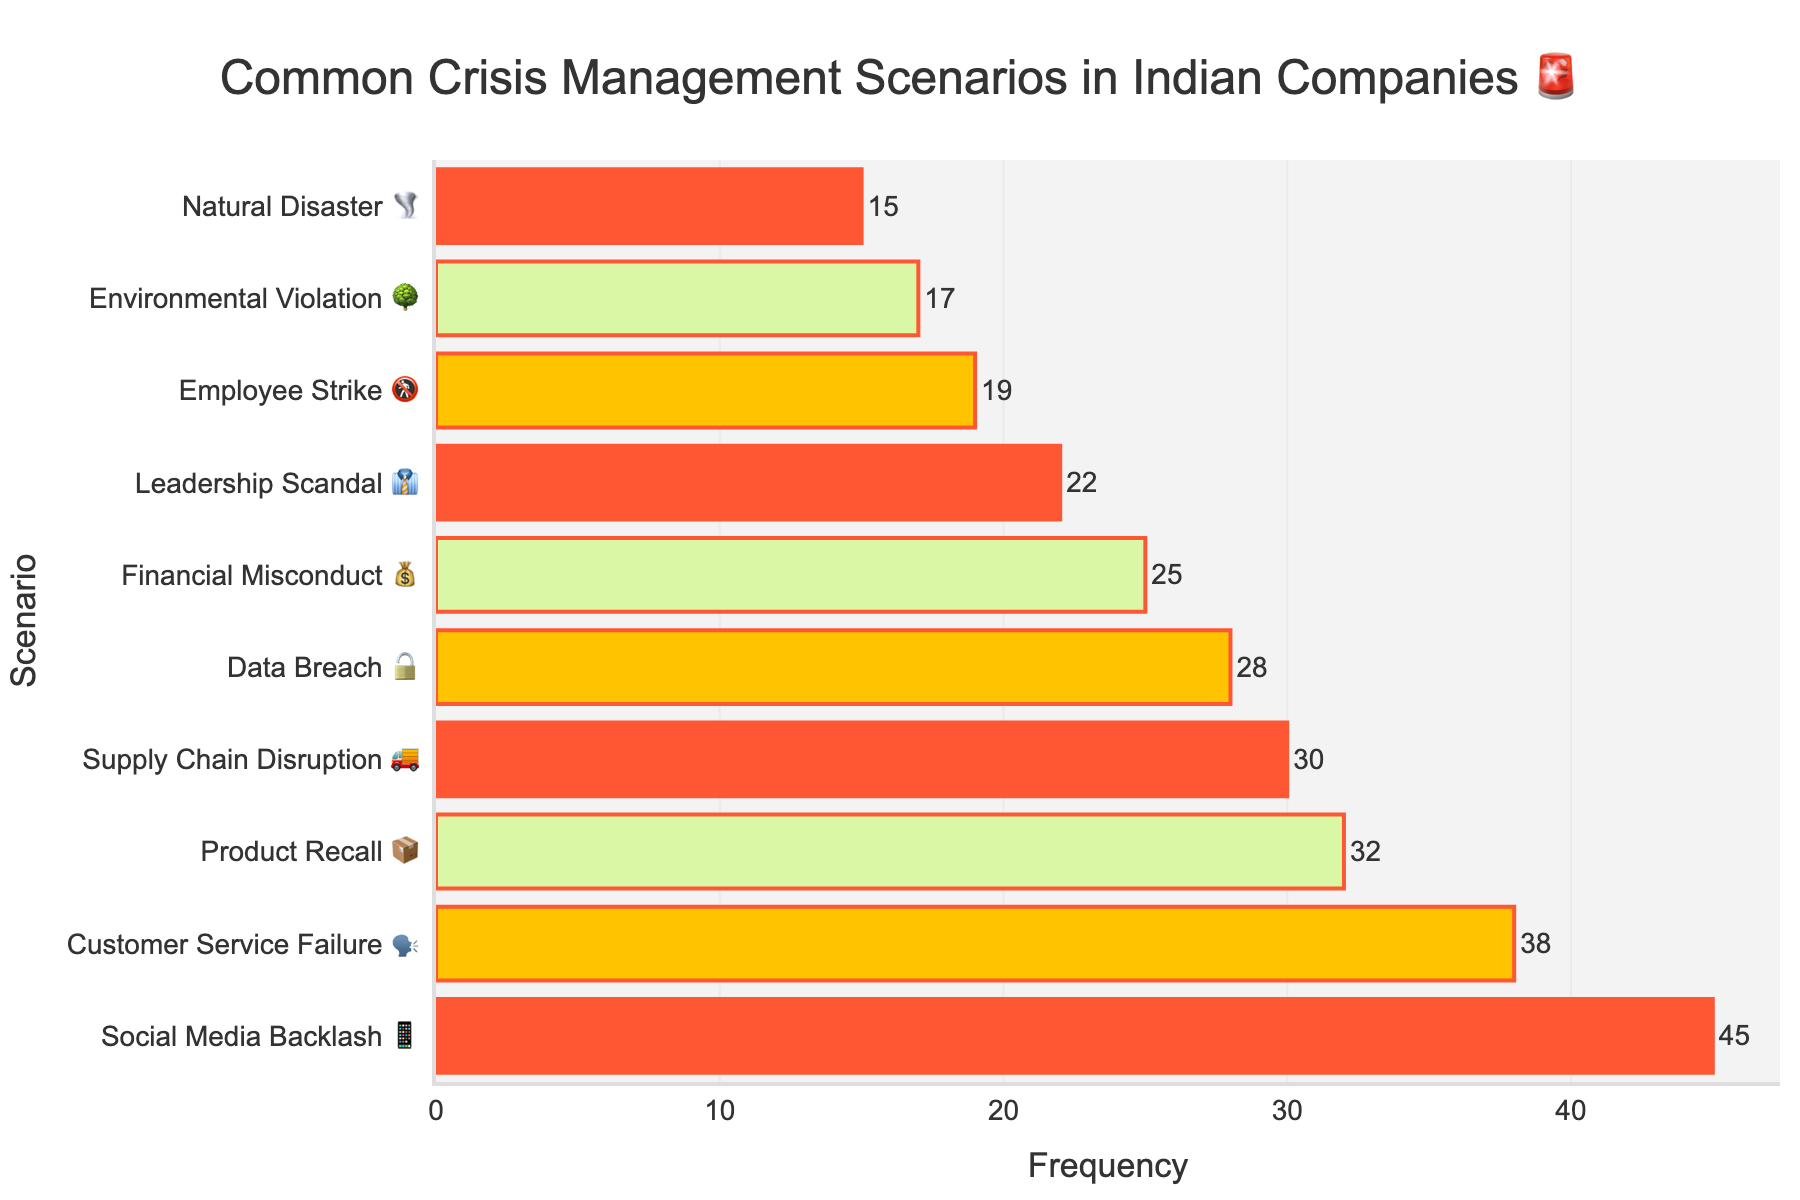Which crisis management scenario has the highest frequency? The bar chart indicates the frequency of each crisis management scenario. The scenario with the tallest bar has the highest frequency. The tallest bar is for "Social Media Backlash 📱" with a frequency of 45.
Answer: Social Media Backlash 📱 What is the frequency of Customer Service Failure 🗣️? Upon inspecting the "Customer Service Failure 🗣️" bar on the chart, the frequency label next to it shows 38.
Answer: 38 How much higher is the frequency of Social Media Backlash 📱 compared to Natural Disaster 🌪️? The frequency of Social Media Backlash 📱 is 45, while Natural Disaster 🌪️ is 15. The difference is 45 - 15 = 30.
Answer: 30 Which scenario has the lowest frequency? By looking at the bars and comparing their heights, the shortest bar represents the scenario with the lowest frequency. The shortest bar is for Natural Disaster 🌪️ with a frequency of 15.
Answer: Natural Disaster 🌪️ What is the cumulative frequency of Product Recall 📦, Data Breach 🔓, and Leadership Scandal 👔? Summing the frequencies of these scenarios: Product Recall 📦 (32), Data Breach 🔓 (28), and Leadership Scandal 👔 (22). The total is 32 + 28 + 22 = 82.
Answer: 82 How many scenarios have a frequency greater than 30? The scenarios with frequencies greater than 30 are "Product Recall 📦" with 32, "Customer Service Failure 🗣️" with 38, and "Social Media Backlash 📱" with 45. This gives us a total of 3 scenarios.
Answer: 3 What are the frequencies of Environmental Violation 🌳 and Supply Chain Disruption 🚚 combined? The frequency of Environmental Violation 🌳 is 17 and Supply Chain Disruption 🚚 is 30. Adding these together results in 17 + 30 = 47.
Answer: 47 Are there more scenarios with a frequency under 20 or over 20? Scenarios under 20: Natural Disaster 🌪️, Employee Strike 🚷, Environmental Violation 🌳 (3 scenarios). Scenarios over 20: Product Recall 📦, Data Breach 🔓, Leadership Scandal 👔, Financial Misconduct 💰, Customer Service Failure 🗣️, Supply Chain Disruption 🚚, Social Media Backlash 📱 (7 scenarios). There are more scenarios over 20.
Answer: Over 20 Which crisis management scenario has the closest frequency to Financial Misconduct 💰? Financial Misconduct 💰 has a frequency of 25. The closest nearby frequencies are Data Breach 🔓 with 28 and Employee Strike 🚷 with 19. Thus, Data Breach 🔓 is the closest to Financial Misconduct 💰.
Answer: Data Breach 🔓 